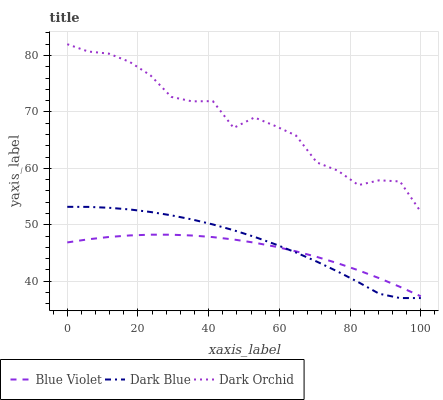Does Dark Orchid have the minimum area under the curve?
Answer yes or no. No. Does Blue Violet have the maximum area under the curve?
Answer yes or no. No. Is Dark Orchid the smoothest?
Answer yes or no. No. Is Blue Violet the roughest?
Answer yes or no. No. Does Blue Violet have the lowest value?
Answer yes or no. No. Does Blue Violet have the highest value?
Answer yes or no. No. Is Dark Blue less than Dark Orchid?
Answer yes or no. Yes. Is Dark Orchid greater than Blue Violet?
Answer yes or no. Yes. Does Dark Blue intersect Dark Orchid?
Answer yes or no. No. 